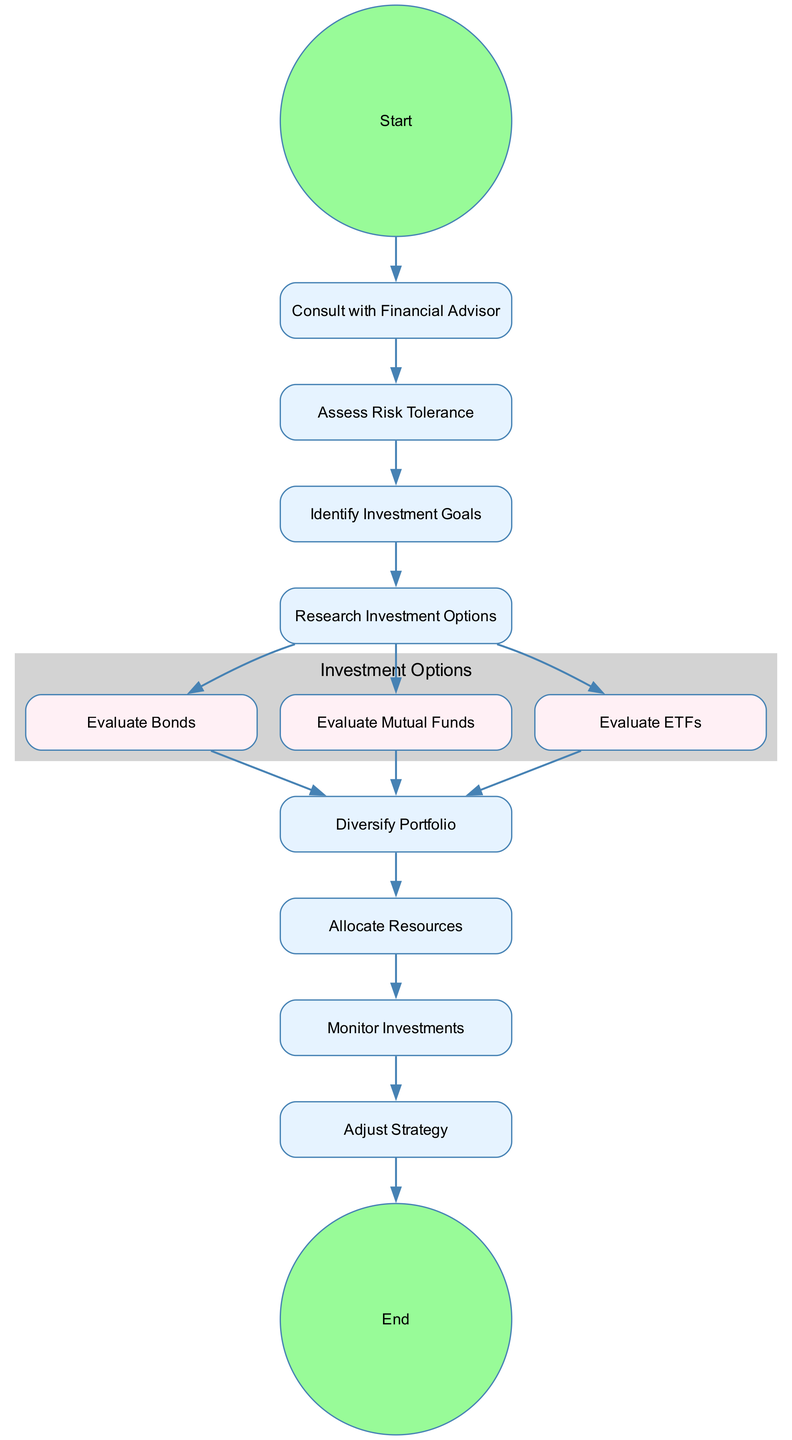What is the first step in the process? The first node in the diagram is "Start," which indicates the beginning of the entire investment selection process. This serves as the initial point before any actions are taken.
Answer: Start How many evaluation options are available in the diagram? The diagram outlines three distinct investment evaluation options: bonds, mutual funds, and ETFs. Each of these is shown as a separate evaluation node following the research phase.
Answer: Three What action follows the "Research Investment Options" node? After "Research Investment Options," the next steps involve evaluating specific investment choices: bonds, mutual funds, and ETFs. This chain of actions illustrates the logical progression after researching options.
Answer: Evaluate Bonds, Evaluate Mutual Funds, Evaluate ETFs What is the final step in the process? The final node in the diagram is labeled "End," which signifies the completion of the investment selection process after all necessary actions have been taken.
Answer: End What is the connection between "Monitor Investments" and "Adjust Strategy"? The flow from "Monitor Investments" to "Adjust Strategy" illustrates that once investments are being monitored, there might be a need to adjust the strategy based on the performance observed during monitoring. It shows a dependency between keeping track of investments and making necessary changes.
Answer: Adjust Strategy Which node represents a decision-making phase? The nodes "Assess Risk Tolerance" and "Identify Investment Goals" indicate necessary decision-making phases where the couple evaluates their preferences and goals before proceeding to research and evaluation. These nodes require thoughtful consideration of personal financial situations.
Answer: Assess Risk Tolerance, Identify Investment Goals After evaluating bonds, what is the next action to take? Once the evaluation of bonds is completed, the process transitions to "Diversify Portfolio", which is essential for reducing risk by spreading investments across various assets. This suggests a broader strategy following specific evaluations.
Answer: Diversify Portfolio How many nodes are connected to the "Research Investment Options"? "Research Investment Options" connects to three evaluation nodes: "Evaluate Bonds," "Evaluate Mutual Funds," and "Evaluate ETFs," demonstrating that this stage leads to multiple evaluation pathways.
Answer: Three 